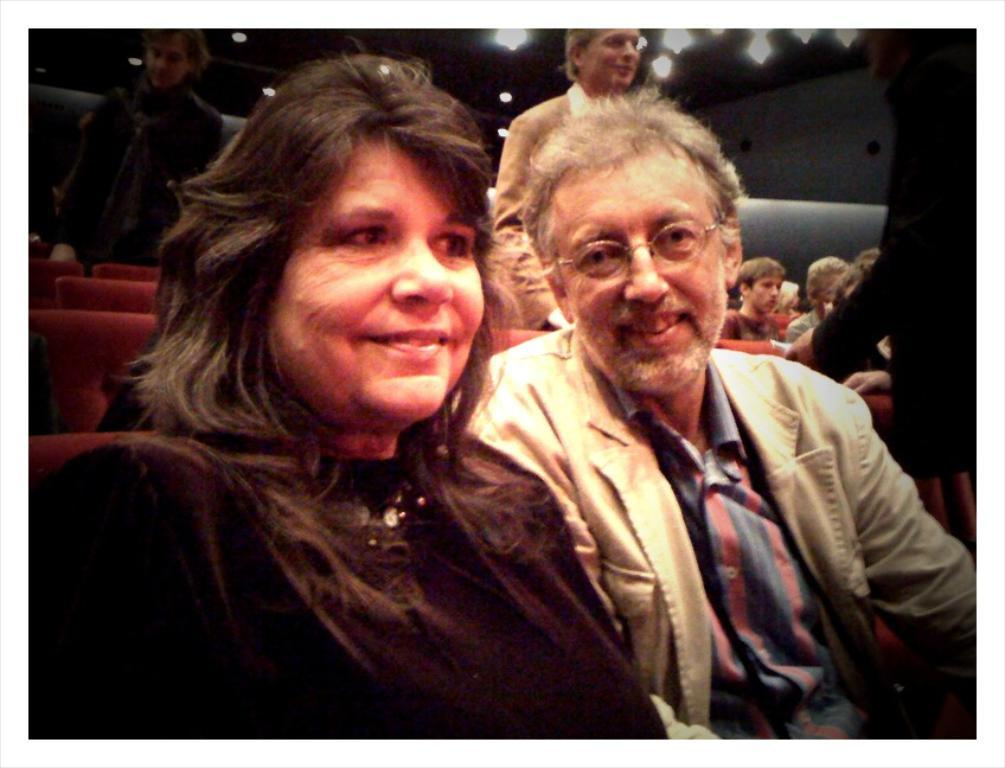What are the people in the image doing? There are people sitting on chairs and people standing in the image. Can you describe the lighting in the image? There are ceiling lights visible in the image. What type of science is being discussed by the queen in the image? There is no queen present in the image, and therefore no discussion about science can be observed. 